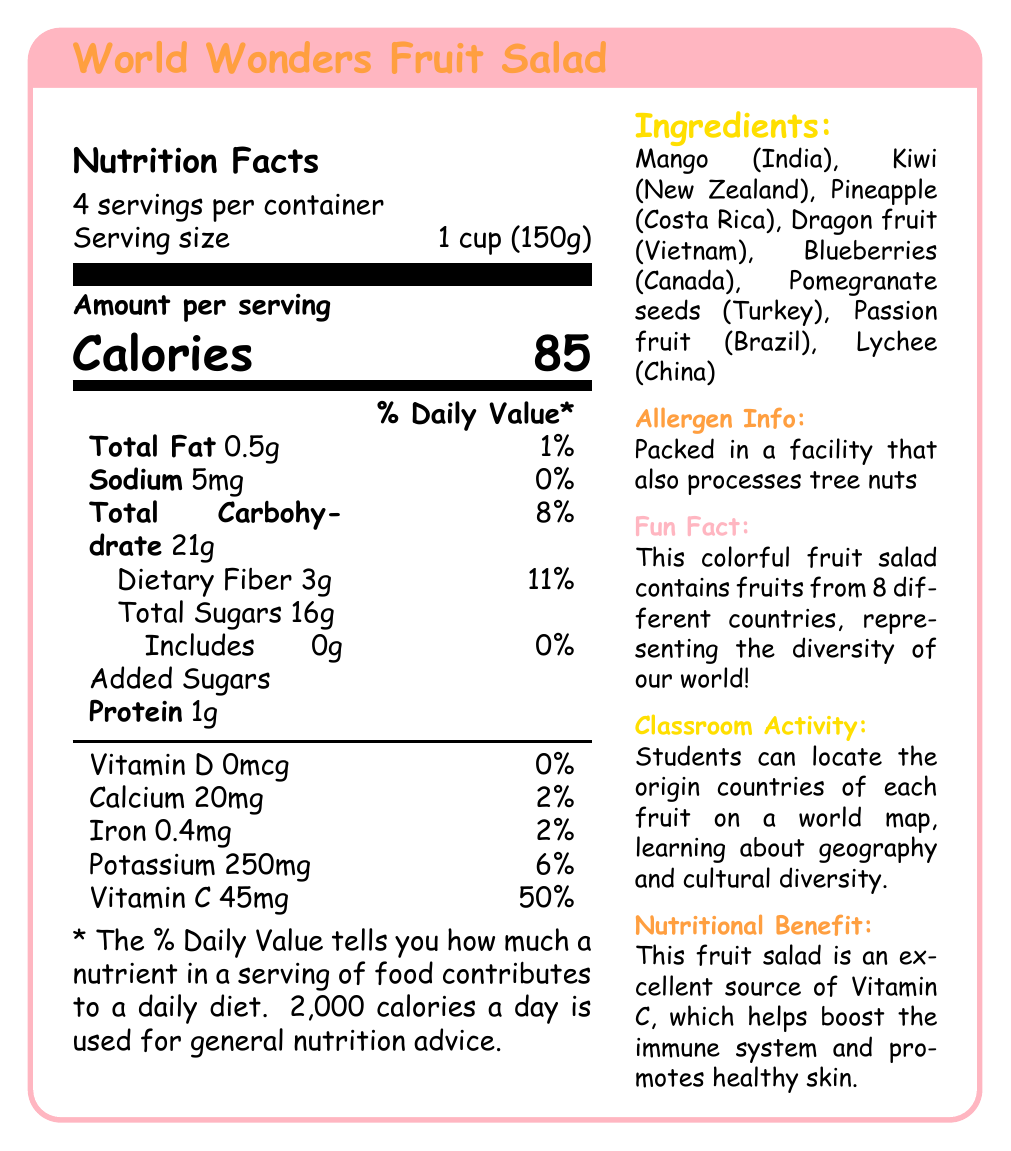How many servings are in the container? The document states that there are 4 servings per container.
Answer: 4 What is the serving size of this fruit salad? The serving size is specified as 1 cup (150g) in the document.
Answer: 1 cup (150g) How many calories are in one serving of the fruit salad? The document lists the number of calories per serving as 85.
Answer: 85 What is the main nutrient this fruit salad is an excellent source of? The document mentions that the fruit salad is an excellent source of Vitamin C, providing 50% of the daily value.
Answer: Vitamin C List the countries of origin for the fruits in this salad. The ingredients section lists the fruits along with their countries of origin: 
- Mango (India)
- Kiwi (New Zealand)
- Pineapple (Costa Rica)
- Dragon fruit (Vietnam)
- Blueberries (Canada)
- Pomegranate seeds (Turkey)
- Passion fruit (Brazil)
- Lychee (China)
Answer: India, New Zealand, Costa Rica, Vietnam, Canada, Turkey, Brazil, China Does the fruit salad contain any added sugars? The document specifies that the total sugars include 0g of added sugars.
Answer: No Which of the following nutrients is present in the highest amount per serving? A. Calcium B. Iron C. Potassium D. Vitamin C The document lists Vitamin C as 45mg (50% daily value), which is higher compared to the others:
- Calcium: 20mg (2%)
- Iron: 0.4mg (2%)
- Potassium: 250mg (6%)
Answer: D. Vitamin C Which vitamin is not present in the fruit salad? A. Vitamin A B. Vitamin D C. Vitamin E D. Vitamin K The document specifies Vitamin D at 0mcg (0% daily value).
Answer: B. Vitamin D Is the fruit salad suitable for someone with a tree nut allergy? The document mentions that the product is packed in a facility that also processes tree nuts, indicating a possible allergy risk.
Answer: Not necessarily Summarize the main idea of the document. The document outlines the nutritional content, ingredients, allergen information, fun fact, classroom activity, and nutritional benefit, emphasizing both the nutritional value and educational aspects of the fruit salad.
Answer: The document provides detailed nutrition facts for the "World Wonders Fruit Salad," highlighting its low calorie and high Vitamin C content. The fruit salad features a variety of fruits from around the world and promotes cultural diversity and health benefits. What is the daily value percentage of dietary fiber in one serving of the fruit salad? The document states that one serving of the fruit salad contains 3g of dietary fiber, which is 11% of the daily value.
Answer: 11% Based on the document, how much protein does one serving contain? The document lists the amount of protein per serving as 1g.
Answer: 1g What is the educational content suggested for classroom activities related to the fruit salad? The document suggests an educational activity where students locate the origins of the fruits on a map to learn about geography and cultural diversity.
Answer: Students can locate the origin countries of each fruit on a world map, learning about geography and cultural diversity. Which fruit in the salad comes from Brazil? The document lists Passion fruit from Brazil as one of the ingredients.
Answer: Passion fruit What are the total carbohydrates in one serving of the fruit salad? The document states that there are 21g of total carbohydrates in one serving.
Answer: 21g Identify the nutrient which contributes the least to the daily value. The document lists Sodium at 5mg, contributing 0% to the daily value.
Answer: Sodium Describe the allergen information provided. The document mentions that the product is packed in a facility that also handles tree nuts, meaning there's a risk of cross-contamination.
Answer: Packed in a facility that also processes tree nuts How many milligrams of calcium are in one serving? The document specifies that one serving contains 20mg of calcium.
Answer: 20mg Is there more potassium or iron in one serving? The document states that one serving contains 250mg of potassium (6% DV) versus 0.4mg of iron (2% DV), showing that potassium is present in higher amounts.
Answer: Potassium Can you determine the price of the fruit salad from the document? The document does not provide any details about the price of the fruit salad.
Answer: Not enough information 